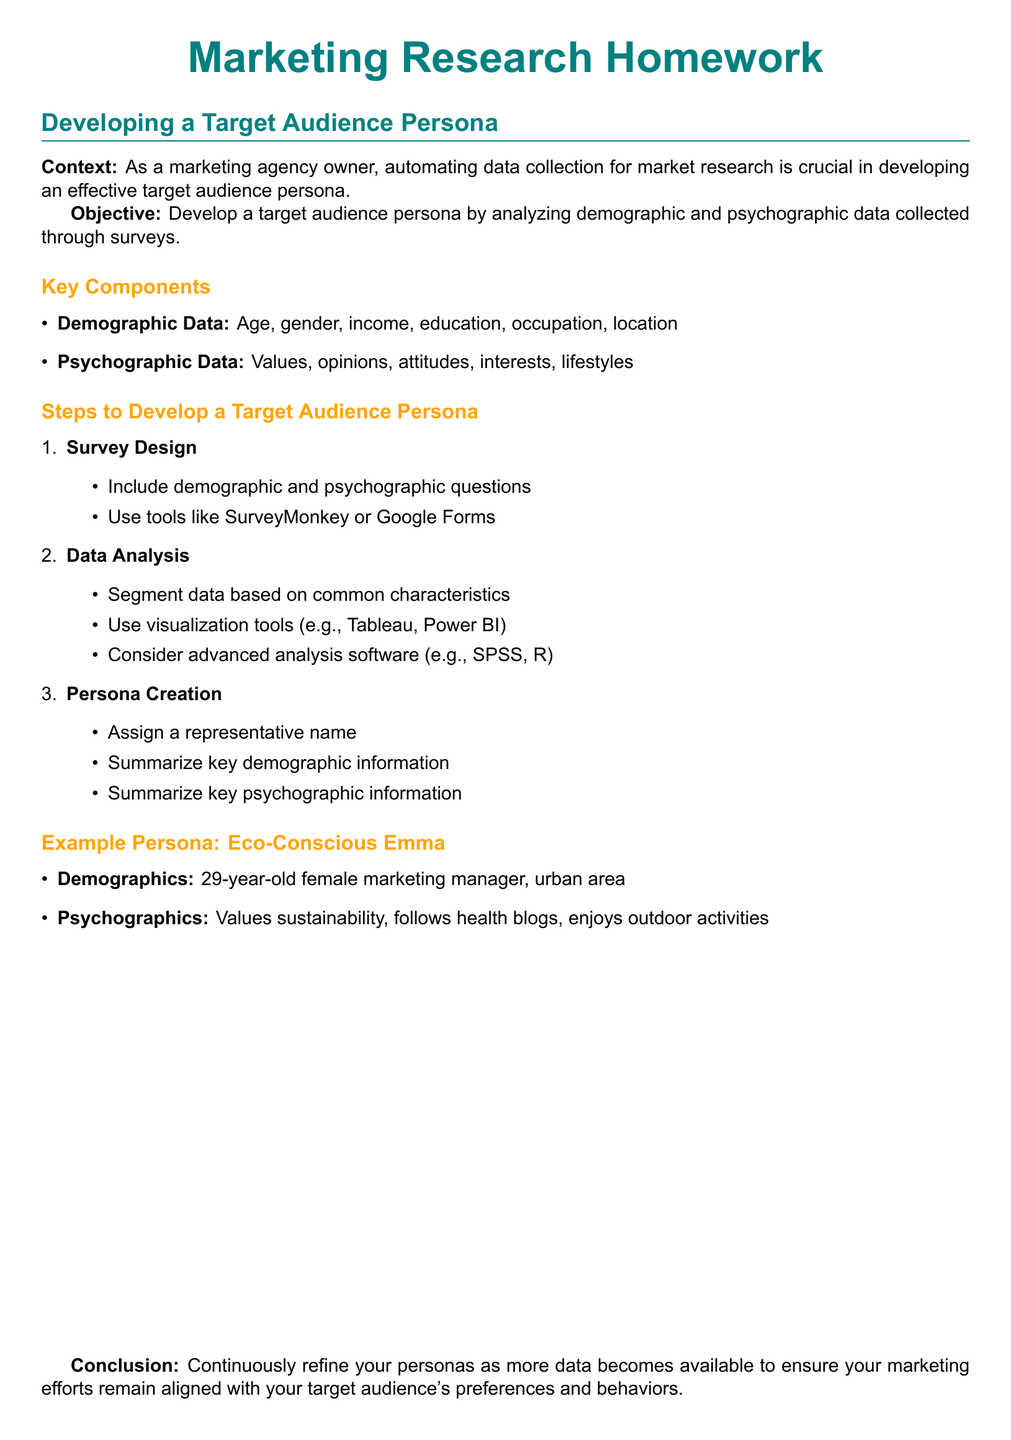what is the title of the document? The title is found in the header section of the document.
Answer: Marketing Research Homework what are the demographic components listed? The document includes specific demographic components under the Key Components section.
Answer: Age, gender, income, education, occupation, location what is the name of the example persona? The name is presented in the Example Persona section, representing the fictional character developed for market research.
Answer: Eco-Conscious Emma how old is the example persona? The age of the persona is specified in the demographics listed in the document.
Answer: 29 years old which survey tools are suggested for data collection? The suggested tools are mentioned in the Survey Design subsection for conducting surveys.
Answer: SurveyMonkey, Google Forms what are two psychographic components mentioned? The document lists psychographic components under the Key Components section, requiring selection from those mentioned.
Answer: Values, interests how many steps are there to develop a target audience persona? The number of steps is indicated in the Steps to Develop a Target Audience Persona section.
Answer: Three which software is recommended for advanced data analysis? The recommended software is provided in the Data Analysis subsection for advanced analysis needs.
Answer: SPSS, R what is the concluding action suggested for persona refinement? The conclusion emphasizes the importance of ongoing adjustments to personas based on data.
Answer: Continuously refine your personas 